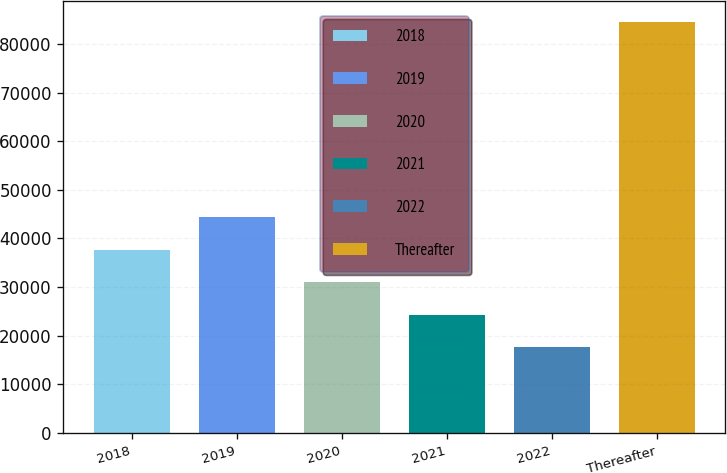<chart> <loc_0><loc_0><loc_500><loc_500><bar_chart><fcel>2018<fcel>2019<fcel>2020<fcel>2021<fcel>2022<fcel>Thereafter<nl><fcel>37684.5<fcel>44384<fcel>30985<fcel>24285.5<fcel>17586<fcel>84581<nl></chart> 